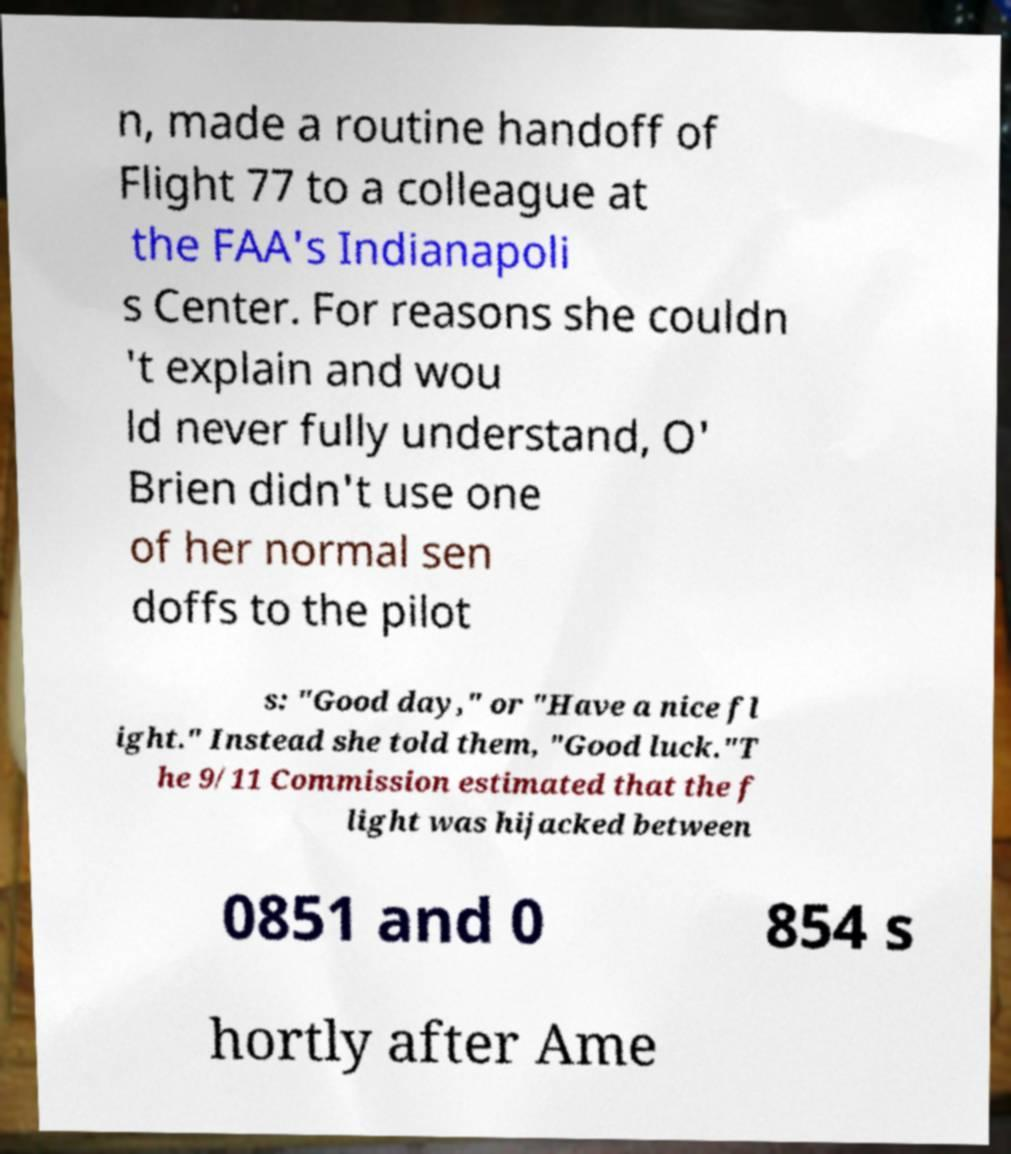Please identify and transcribe the text found in this image. n, made a routine handoff of Flight 77 to a colleague at the FAA's Indianapoli s Center. For reasons she couldn 't explain and wou ld never fully understand, O' Brien didn't use one of her normal sen doffs to the pilot s: "Good day," or "Have a nice fl ight." Instead she told them, "Good luck."T he 9/11 Commission estimated that the f light was hijacked between 0851 and 0 854 s hortly after Ame 